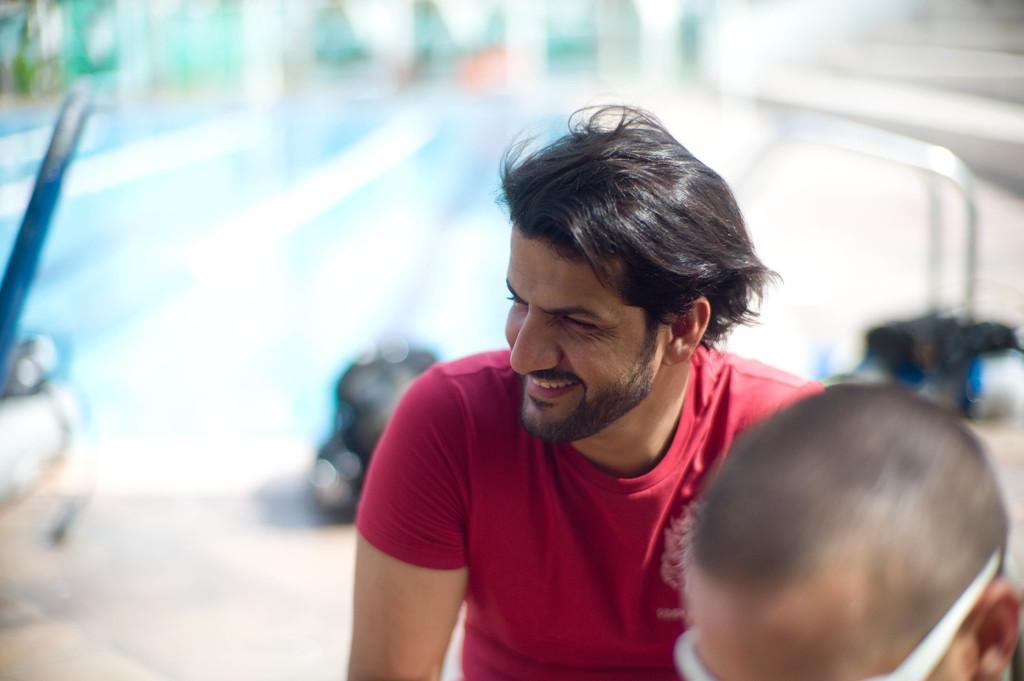Can you describe this image briefly? A man is there, he wore red color t-shirt, he is smiling. 